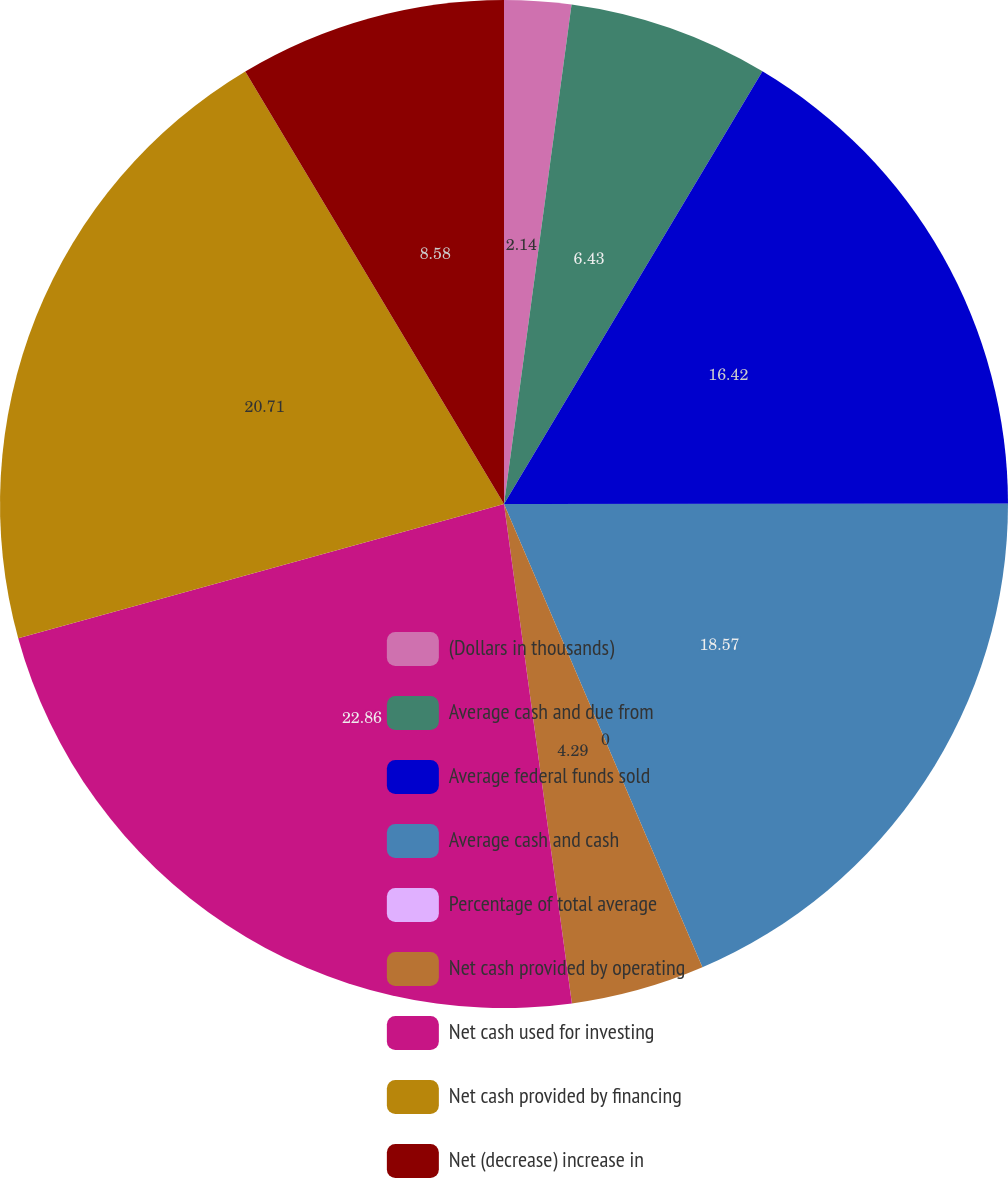Convert chart to OTSL. <chart><loc_0><loc_0><loc_500><loc_500><pie_chart><fcel>(Dollars in thousands)<fcel>Average cash and due from<fcel>Average federal funds sold<fcel>Average cash and cash<fcel>Percentage of total average<fcel>Net cash provided by operating<fcel>Net cash used for investing<fcel>Net cash provided by financing<fcel>Net (decrease) increase in<nl><fcel>2.14%<fcel>6.43%<fcel>16.42%<fcel>18.57%<fcel>0.0%<fcel>4.29%<fcel>22.86%<fcel>20.71%<fcel>8.58%<nl></chart> 